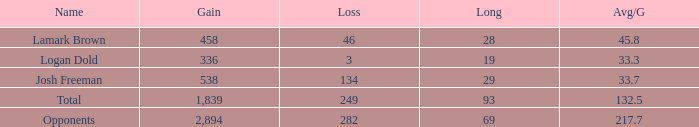How much Gain has a Long of 29, and an Avg/G smaller than 33.7? 0.0. 